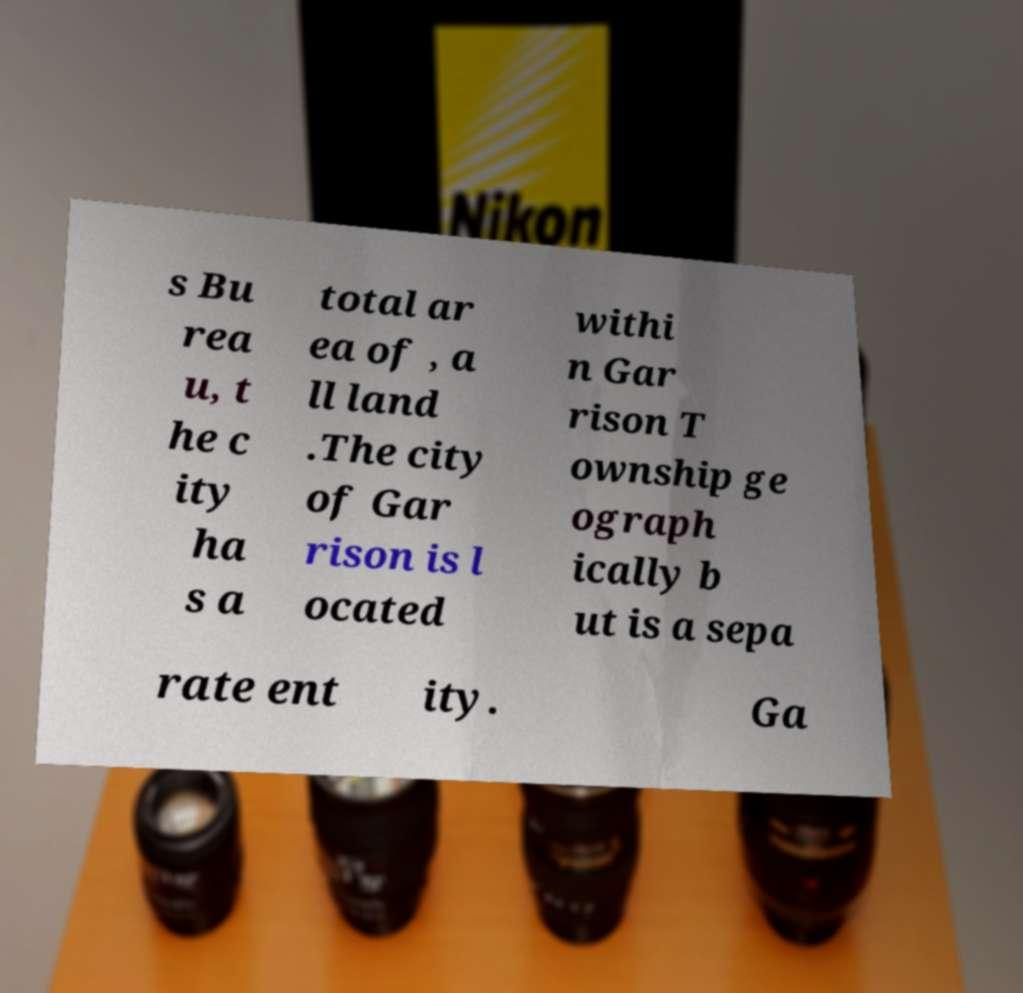Please read and relay the text visible in this image. What does it say? s Bu rea u, t he c ity ha s a total ar ea of , a ll land .The city of Gar rison is l ocated withi n Gar rison T ownship ge ograph ically b ut is a sepa rate ent ity. Ga 